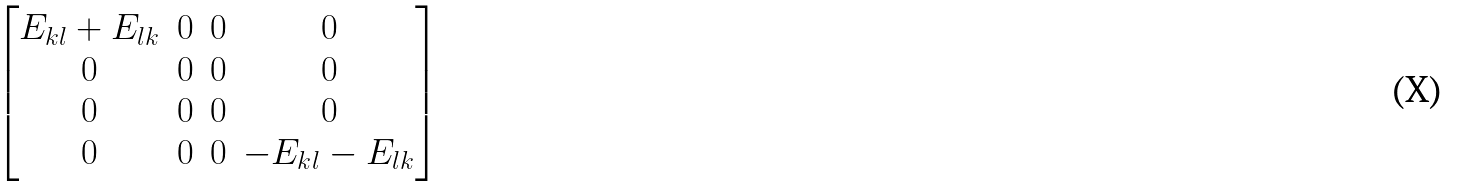<formula> <loc_0><loc_0><loc_500><loc_500>\begin{bmatrix} E _ { k l } + E _ { l k } & 0 & 0 & 0 \\ 0 & 0 & 0 & 0 \\ 0 & 0 & 0 & 0 \\ 0 & 0 & 0 & - E _ { k l } - E _ { l k } \end{bmatrix}</formula> 